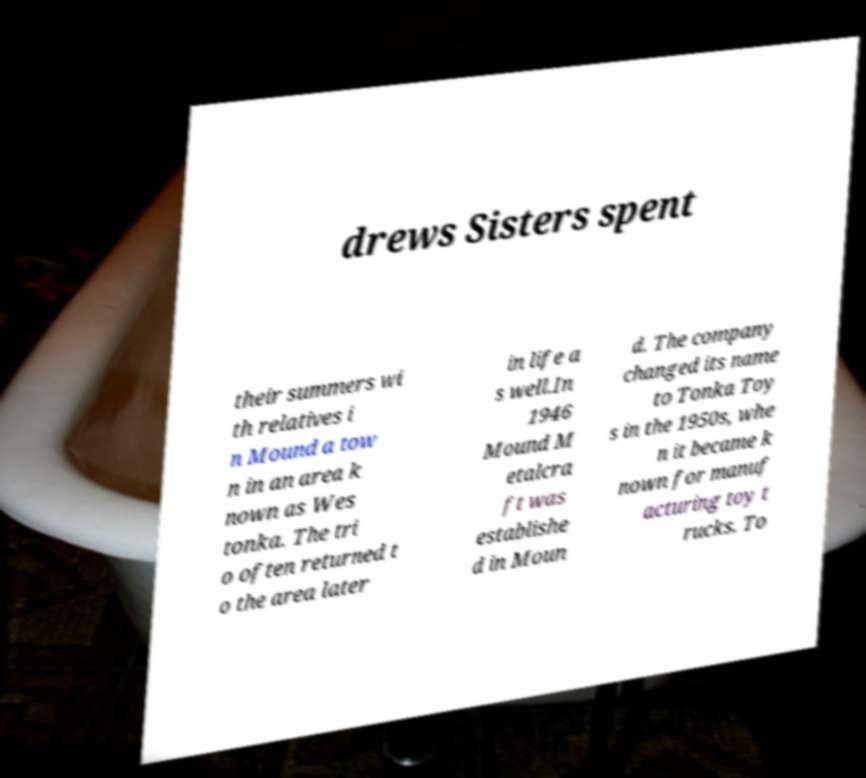I need the written content from this picture converted into text. Can you do that? drews Sisters spent their summers wi th relatives i n Mound a tow n in an area k nown as Wes tonka. The tri o often returned t o the area later in life a s well.In 1946 Mound M etalcra ft was establishe d in Moun d. The company changed its name to Tonka Toy s in the 1950s, whe n it became k nown for manuf acturing toy t rucks. To 